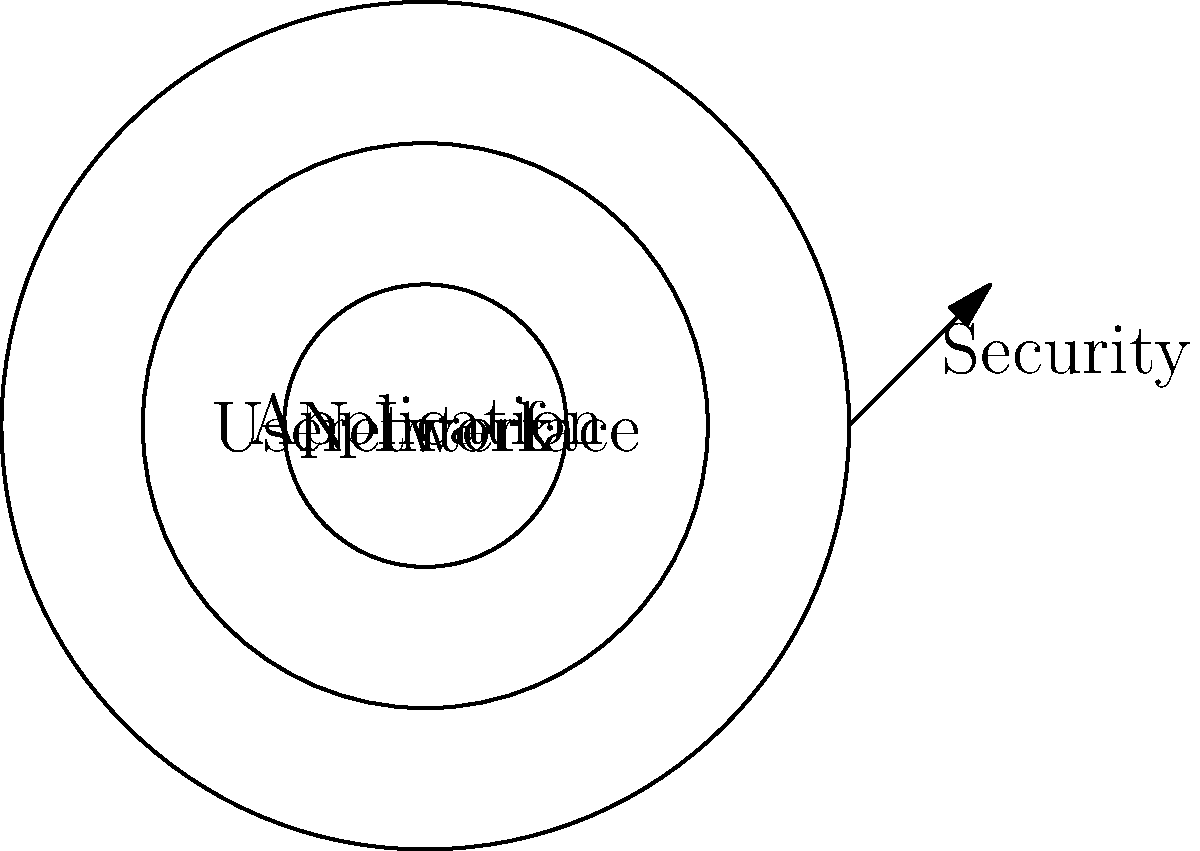In the diagram, which layer is most directly impacted by the web designer's focus on aesthetics and user experience, and how does this relate to network security? To answer this question, let's analyze the diagram and consider the web designer's priorities:

1. The diagram shows three concentric circles representing different layers:
   - Innermost: Network
   - Middle: Application
   - Outermost: User Interface

2. As a web designer focusing on aesthetics and user experience, the primary concern is the User Interface layer.

3. The arrow pointing inward from the outer edge is labeled "Security," indicating that security considerations affect all layers.

4. The relationship between UI design and network security:
   a. UI design can influence security by:
      - Implementing clear visual cues for secure connections (e.g., HTTPS indicators)
      - Designing intuitive password strength meters
      - Creating user-friendly two-factor authentication interfaces

   b. However, the UI layer is the furthest from the core Network layer, meaning:
      - Changes in UI design have less direct impact on core network security
      - UI design focuses more on user perception and interaction with security features

5. The web designer's role in security:
   - Collaborate with security experts to ensure UI elements accurately reflect the system's security status
   - Design interfaces that encourage secure user behavior without compromising aesthetics or usability

Therefore, while the User Interface layer is most directly impacted by the web designer's focus, it has an indirect but important relationship with network security through user interaction and perception.
Answer: User Interface layer; indirect impact through user interaction and security perception 